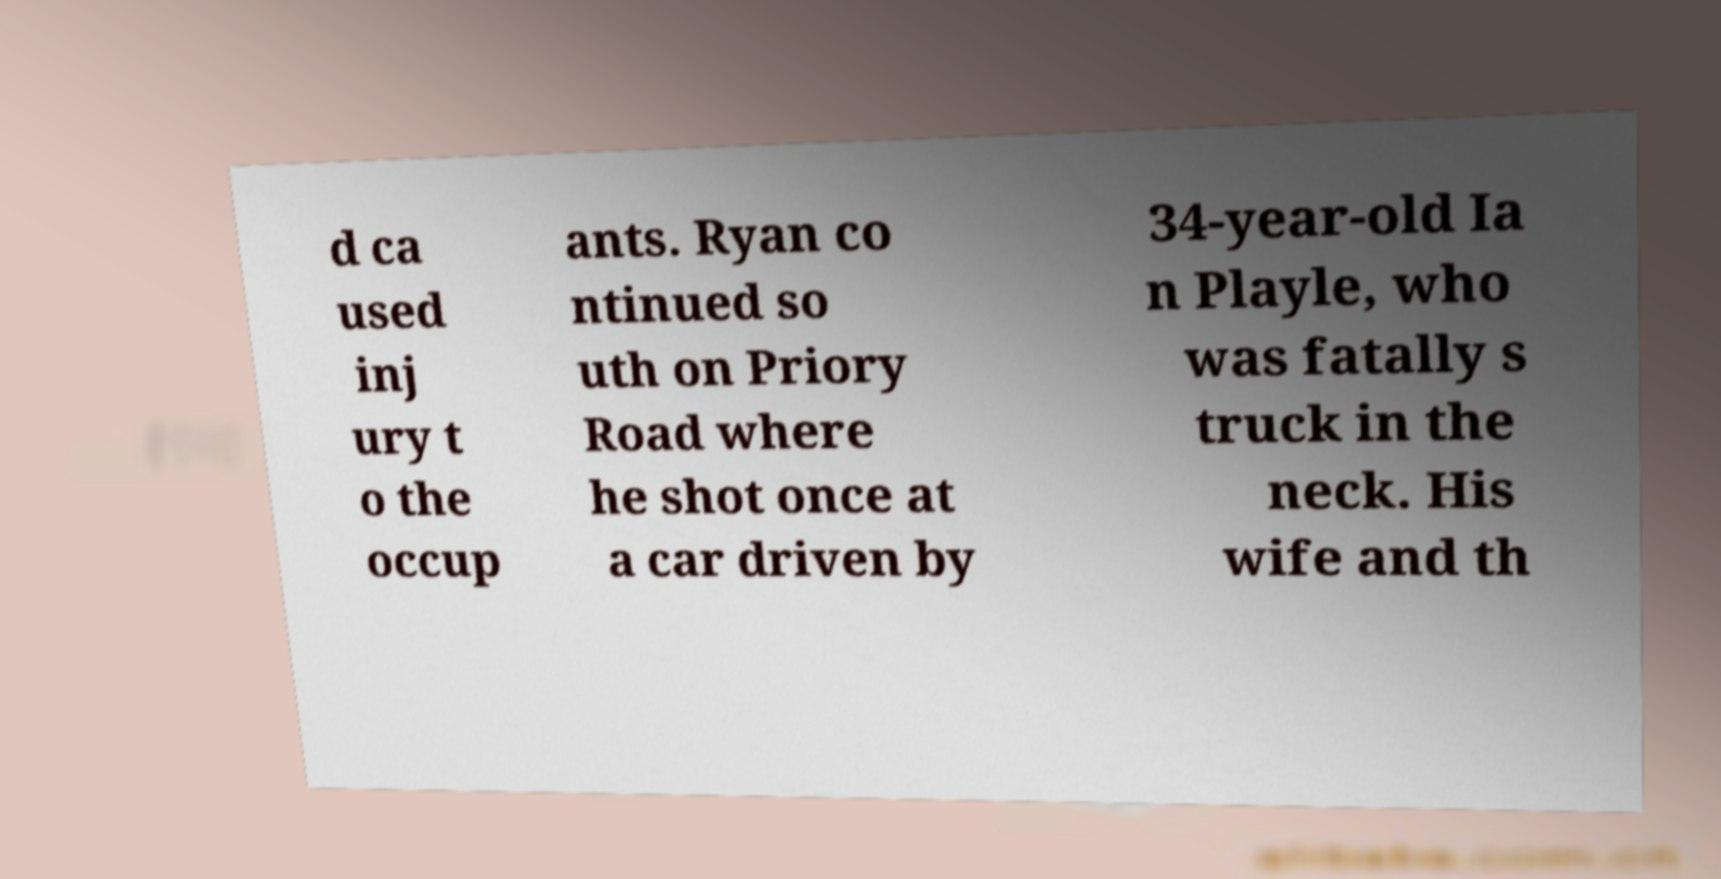There's text embedded in this image that I need extracted. Can you transcribe it verbatim? d ca used inj ury t o the occup ants. Ryan co ntinued so uth on Priory Road where he shot once at a car driven by 34-year-old Ia n Playle, who was fatally s truck in the neck. His wife and th 